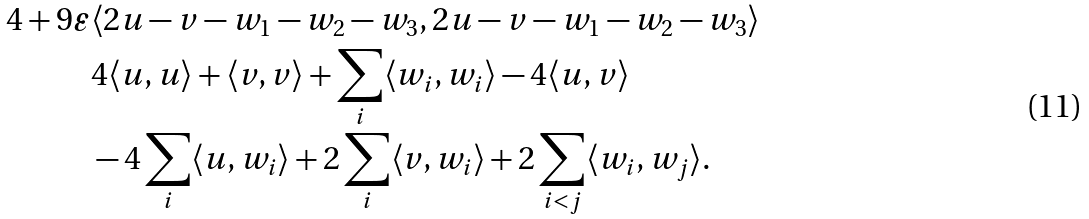Convert formula to latex. <formula><loc_0><loc_0><loc_500><loc_500>4 + 9 \varepsilon & \langle 2 u - v - w _ { 1 } - w _ { 2 } - w _ { 3 } , 2 u - v - w _ { 1 } - w _ { 2 } - w _ { 3 } \rangle \\ & 4 \langle u , u \rangle + \langle v , v \rangle + \sum _ { i } \langle w _ { i } , w _ { i } \rangle - 4 \langle u , v \rangle \\ & - 4 \sum _ { i } \langle u , w _ { i } \rangle + 2 \sum _ { i } \langle v , w _ { i } \rangle + 2 \sum _ { i < j } \langle w _ { i } , w _ { j } \rangle .</formula> 